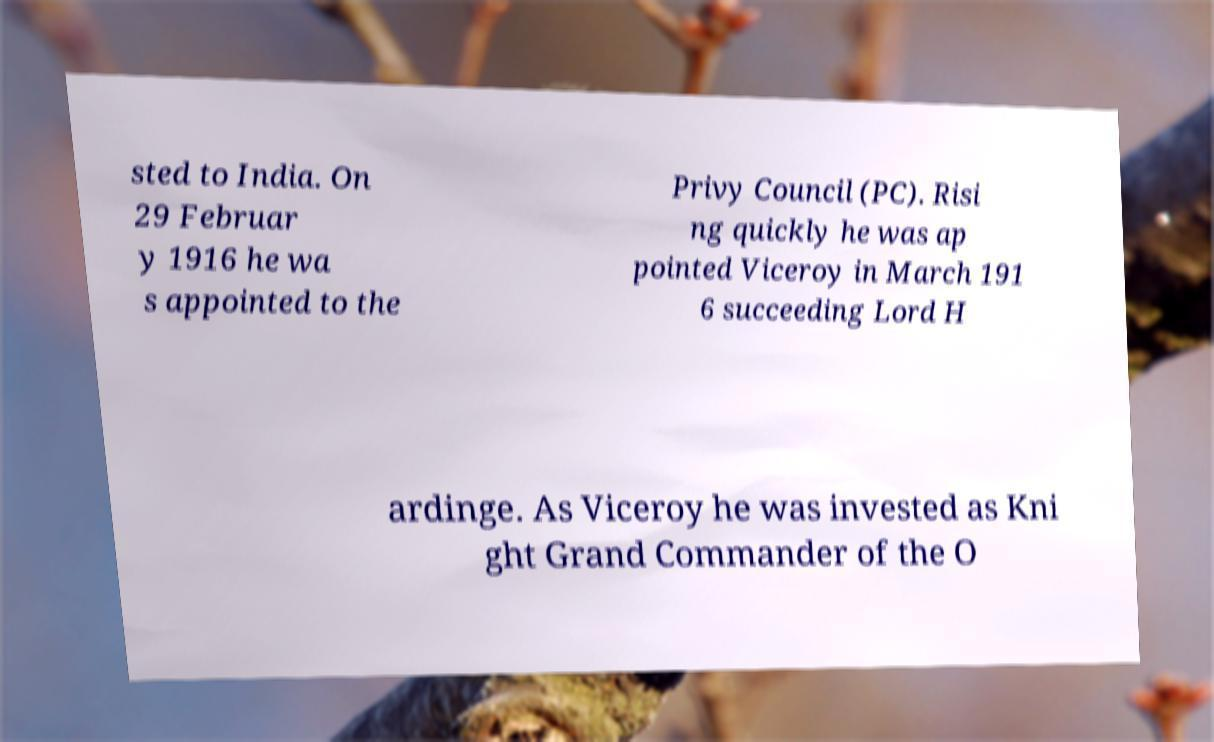Can you accurately transcribe the text from the provided image for me? sted to India. On 29 Februar y 1916 he wa s appointed to the Privy Council (PC). Risi ng quickly he was ap pointed Viceroy in March 191 6 succeeding Lord H ardinge. As Viceroy he was invested as Kni ght Grand Commander of the O 